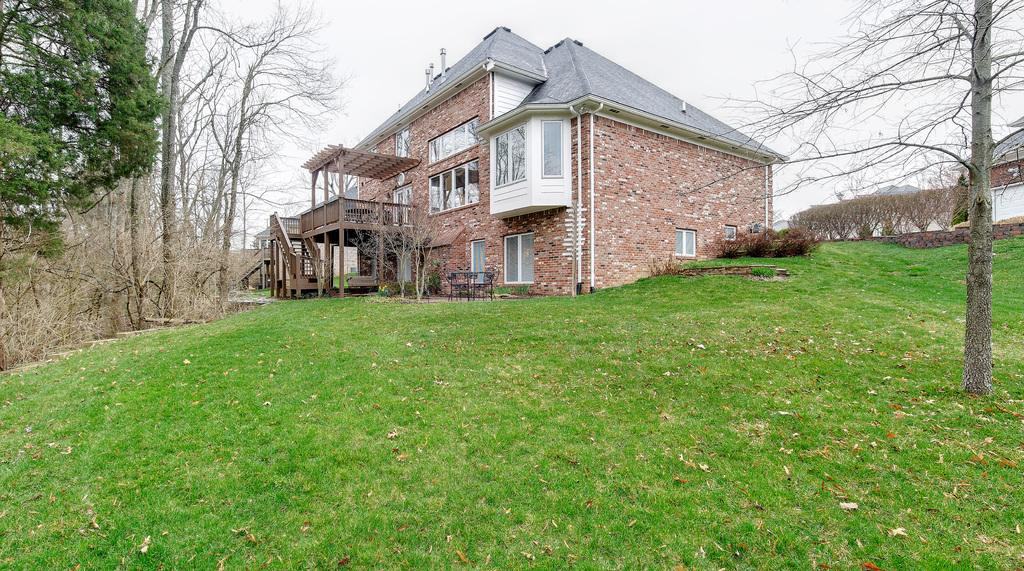What type of structures can be seen in the image? There are houses in the image. What type of vegetation is visible in the image? There is grass visible in the image. What other natural elements can be seen in the image? There are trees in the image. What type of beef is being cooked on the pan in the image? There is no pan or beef present in the image. 